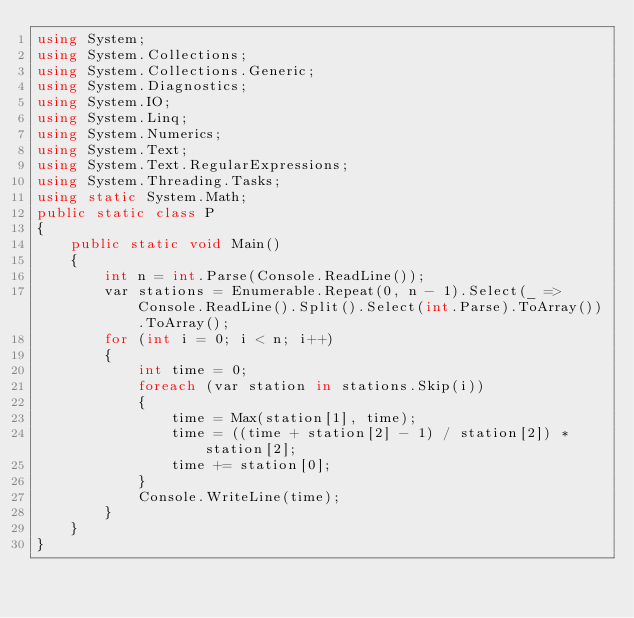Convert code to text. <code><loc_0><loc_0><loc_500><loc_500><_C#_>using System;
using System.Collections;
using System.Collections.Generic;
using System.Diagnostics;
using System.IO;
using System.Linq;
using System.Numerics;
using System.Text;
using System.Text.RegularExpressions;
using System.Threading.Tasks;
using static System.Math;
public static class P
{
    public static void Main()
    {
        int n = int.Parse(Console.ReadLine());
        var stations = Enumerable.Repeat(0, n - 1).Select(_ => Console.ReadLine().Split().Select(int.Parse).ToArray()).ToArray();
        for (int i = 0; i < n; i++)
        {
            int time = 0;
            foreach (var station in stations.Skip(i))
            {
                time = Max(station[1], time);
                time = ((time + station[2] - 1) / station[2]) * station[2];
                time += station[0];
            }
            Console.WriteLine(time);
        }
    }
}
</code> 